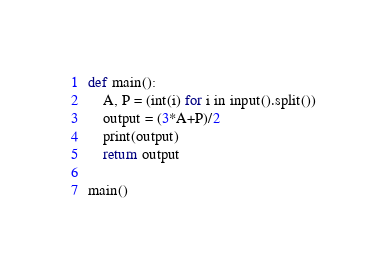Convert code to text. <code><loc_0><loc_0><loc_500><loc_500><_Python_>def main():
    A, P = (int(i) for i in input().split())
    output = (3*A+P)/2
    print(output)
    return output

main()</code> 